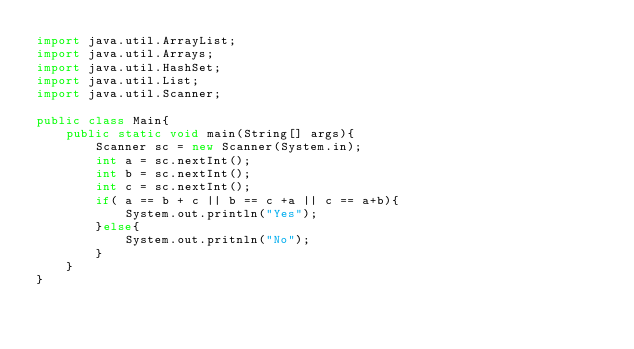<code> <loc_0><loc_0><loc_500><loc_500><_Java_>import java.util.ArrayList;
import java.util.Arrays;
import java.util.HashSet;
import java.util.List;
import java.util.Scanner;

public class Main{
    public static void main(String[] args){
        Scanner sc = new Scanner(System.in);
        int a = sc.nextInt();
        int b = sc.nextInt();
        int c = sc.nextInt();
        if( a == b + c || b == c +a || c == a+b){
            System.out.println("Yes");
        }else{
            System.out.pritnln("No");
        }        
    }
}
</code> 